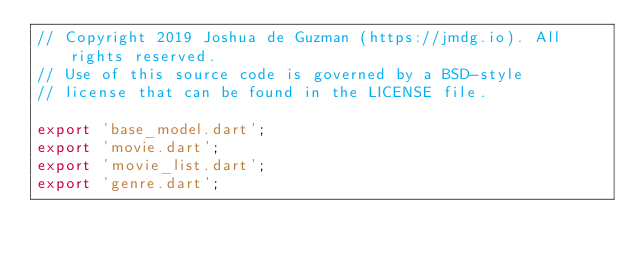Convert code to text. <code><loc_0><loc_0><loc_500><loc_500><_Dart_>// Copyright 2019 Joshua de Guzman (https://jmdg.io). All rights reserved.
// Use of this source code is governed by a BSD-style
// license that can be found in the LICENSE file.

export 'base_model.dart';
export 'movie.dart';
export 'movie_list.dart';
export 'genre.dart';
</code> 